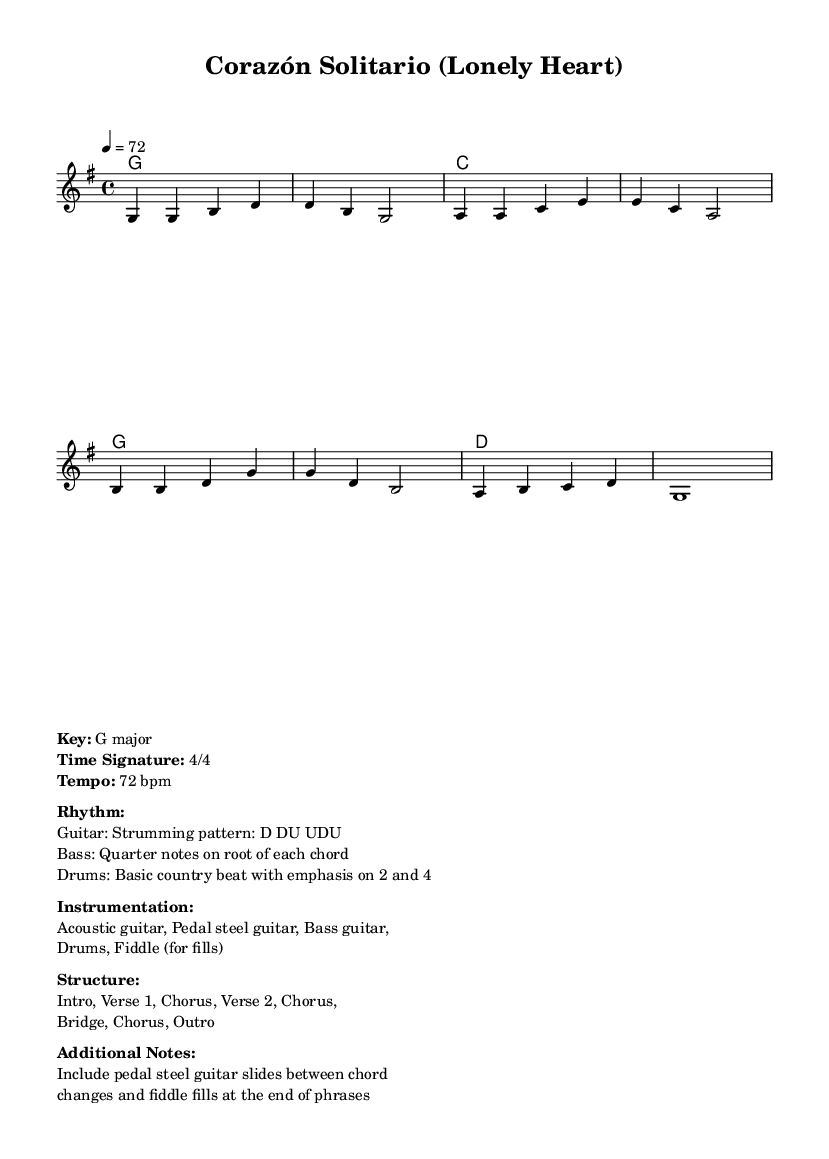What is the key signature of this music? The key signature is G major, which has one sharp (F#). This is identified by the key signature indicated at the beginning of the score.
Answer: G major What is the time signature of this music? The time signature is 4/4, indicated at the beginning of the composition. It shows that there are four beats in a measure and a quarter note receives one beat.
Answer: 4/4 What is the tempo of this song? The tempo is 72 bpm (beats per minute), which tells us the speed at which the piece should be played. This can be found at the start of the score, directly noted next to the tempo mark.
Answer: 72 bpm How many verses are in the structure? The structure indicates two verses, as outlined in the provided sections of the music that include a Verse 1 and Verse 2. This can be derived from the structure section marked in the score.
Answer: 2 What is the primary instrumentation used in this piece? The primary instrumentation includes acoustic guitar, pedal steel guitar, bass guitar, drums, and fiddle. This information is listed under the instrumentation section of the markup, which details the instruments involved in performance.
Answer: Acoustic guitar, pedal steel guitar, bass guitar, drums, fiddle Describe the strumming pattern for the guitar. The strumming pattern for the guitar is Down, Down-Up, Up-Down-Up (D DU UDU). This is shown under the rhythm section and describes how the guitar should be strummed throughout the song.
Answer: D DU UDU 